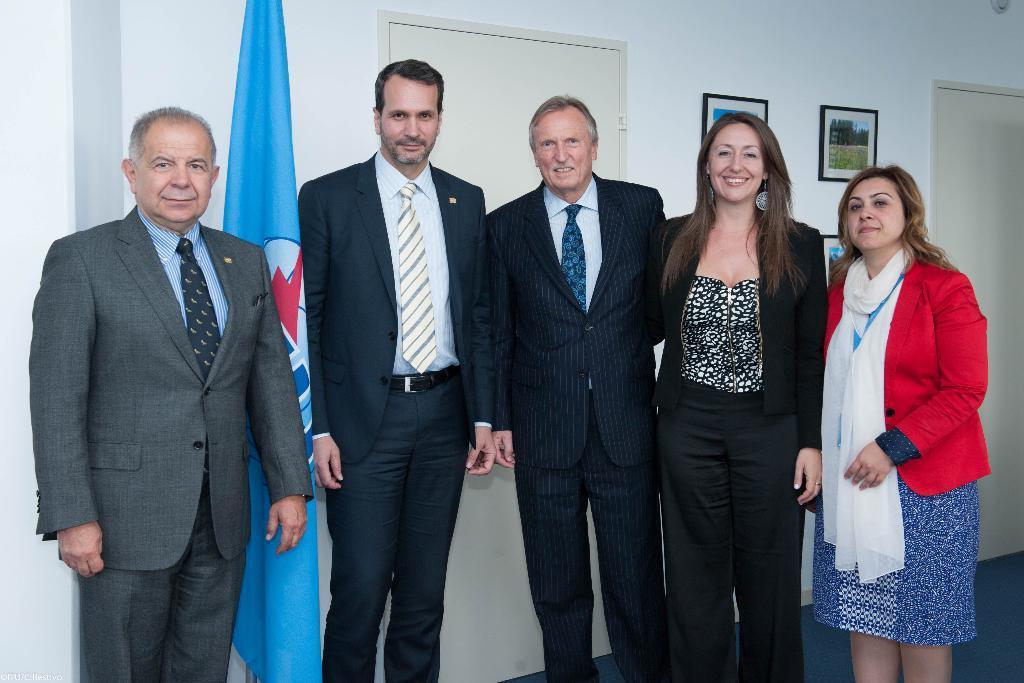How would you summarize this image in a sentence or two? In this image we can see a few people standing and smiling, there are some doors and a flag, on the wall we can see some photo frames. 